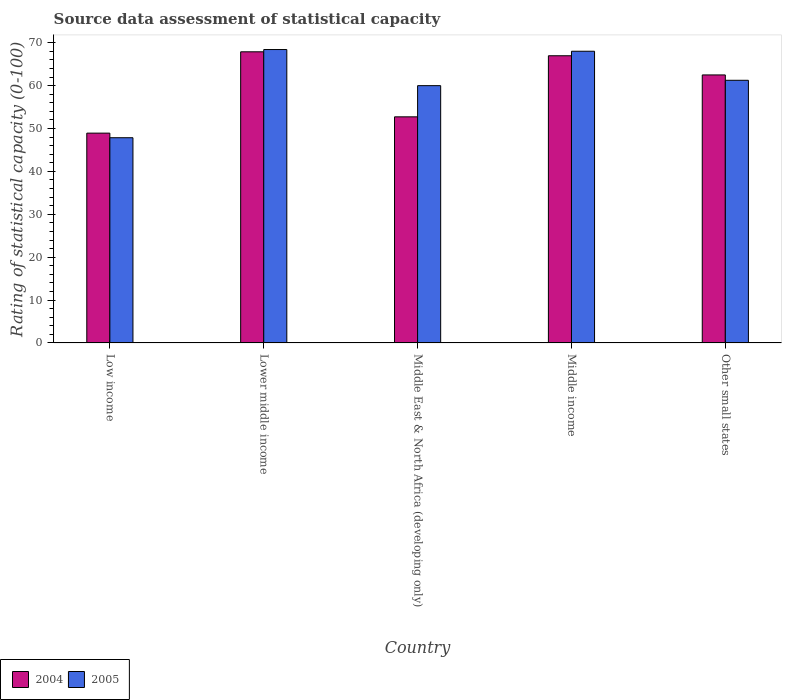How many different coloured bars are there?
Provide a short and direct response. 2. How many groups of bars are there?
Offer a terse response. 5. Are the number of bars per tick equal to the number of legend labels?
Offer a terse response. Yes. How many bars are there on the 1st tick from the left?
Keep it short and to the point. 2. What is the label of the 4th group of bars from the left?
Provide a succinct answer. Middle income. In how many cases, is the number of bars for a given country not equal to the number of legend labels?
Your answer should be compact. 0. What is the rating of statistical capacity in 2004 in Low income?
Keep it short and to the point. 48.93. Across all countries, what is the maximum rating of statistical capacity in 2004?
Provide a succinct answer. 67.89. Across all countries, what is the minimum rating of statistical capacity in 2005?
Give a very brief answer. 47.86. In which country was the rating of statistical capacity in 2004 maximum?
Make the answer very short. Lower middle income. In which country was the rating of statistical capacity in 2004 minimum?
Keep it short and to the point. Low income. What is the total rating of statistical capacity in 2005 in the graph?
Your response must be concise. 305.55. What is the difference between the rating of statistical capacity in 2005 in Low income and that in Middle East & North Africa (developing only)?
Give a very brief answer. -12.14. What is the difference between the rating of statistical capacity in 2004 in Middle income and the rating of statistical capacity in 2005 in Lower middle income?
Provide a succinct answer. -1.45. What is the average rating of statistical capacity in 2004 per country?
Your answer should be compact. 59.8. What is the difference between the rating of statistical capacity of/in 2005 and rating of statistical capacity of/in 2004 in Lower middle income?
Your response must be concise. 0.53. In how many countries, is the rating of statistical capacity in 2005 greater than 62?
Keep it short and to the point. 2. What is the ratio of the rating of statistical capacity in 2004 in Lower middle income to that in Other small states?
Give a very brief answer. 1.09. Is the rating of statistical capacity in 2004 in Low income less than that in Middle income?
Offer a terse response. Yes. Is the difference between the rating of statistical capacity in 2005 in Middle East & North Africa (developing only) and Middle income greater than the difference between the rating of statistical capacity in 2004 in Middle East & North Africa (developing only) and Middle income?
Offer a very short reply. Yes. What is the difference between the highest and the second highest rating of statistical capacity in 2004?
Give a very brief answer. -0.92. What is the difference between the highest and the lowest rating of statistical capacity in 2005?
Provide a succinct answer. 20.56. In how many countries, is the rating of statistical capacity in 2005 greater than the average rating of statistical capacity in 2005 taken over all countries?
Provide a short and direct response. 3. Is the sum of the rating of statistical capacity in 2004 in Lower middle income and Middle East & North Africa (developing only) greater than the maximum rating of statistical capacity in 2005 across all countries?
Keep it short and to the point. Yes. What does the 2nd bar from the left in Middle income represents?
Your response must be concise. 2005. Are all the bars in the graph horizontal?
Offer a terse response. No. How many countries are there in the graph?
Provide a succinct answer. 5. Does the graph contain any zero values?
Ensure brevity in your answer.  No. Does the graph contain grids?
Provide a succinct answer. No. Where does the legend appear in the graph?
Keep it short and to the point. Bottom left. How many legend labels are there?
Your response must be concise. 2. How are the legend labels stacked?
Provide a short and direct response. Horizontal. What is the title of the graph?
Your response must be concise. Source data assessment of statistical capacity. Does "1991" appear as one of the legend labels in the graph?
Your answer should be compact. No. What is the label or title of the X-axis?
Ensure brevity in your answer.  Country. What is the label or title of the Y-axis?
Make the answer very short. Rating of statistical capacity (0-100). What is the Rating of statistical capacity (0-100) of 2004 in Low income?
Make the answer very short. 48.93. What is the Rating of statistical capacity (0-100) in 2005 in Low income?
Ensure brevity in your answer.  47.86. What is the Rating of statistical capacity (0-100) in 2004 in Lower middle income?
Provide a succinct answer. 67.89. What is the Rating of statistical capacity (0-100) of 2005 in Lower middle income?
Provide a short and direct response. 68.42. What is the Rating of statistical capacity (0-100) of 2004 in Middle East & North Africa (developing only)?
Ensure brevity in your answer.  52.73. What is the Rating of statistical capacity (0-100) of 2005 in Middle East & North Africa (developing only)?
Offer a terse response. 60. What is the Rating of statistical capacity (0-100) of 2004 in Middle income?
Offer a very short reply. 66.97. What is the Rating of statistical capacity (0-100) of 2005 in Middle income?
Keep it short and to the point. 68.03. What is the Rating of statistical capacity (0-100) of 2004 in Other small states?
Provide a succinct answer. 62.5. What is the Rating of statistical capacity (0-100) in 2005 in Other small states?
Ensure brevity in your answer.  61.25. Across all countries, what is the maximum Rating of statistical capacity (0-100) in 2004?
Offer a very short reply. 67.89. Across all countries, what is the maximum Rating of statistical capacity (0-100) of 2005?
Your response must be concise. 68.42. Across all countries, what is the minimum Rating of statistical capacity (0-100) of 2004?
Provide a succinct answer. 48.93. Across all countries, what is the minimum Rating of statistical capacity (0-100) of 2005?
Offer a very short reply. 47.86. What is the total Rating of statistical capacity (0-100) in 2004 in the graph?
Offer a terse response. 299.02. What is the total Rating of statistical capacity (0-100) of 2005 in the graph?
Provide a succinct answer. 305.55. What is the difference between the Rating of statistical capacity (0-100) in 2004 in Low income and that in Lower middle income?
Keep it short and to the point. -18.97. What is the difference between the Rating of statistical capacity (0-100) of 2005 in Low income and that in Lower middle income?
Give a very brief answer. -20.56. What is the difference between the Rating of statistical capacity (0-100) in 2004 in Low income and that in Middle East & North Africa (developing only)?
Your answer should be compact. -3.8. What is the difference between the Rating of statistical capacity (0-100) of 2005 in Low income and that in Middle East & North Africa (developing only)?
Your answer should be very brief. -12.14. What is the difference between the Rating of statistical capacity (0-100) in 2004 in Low income and that in Middle income?
Your answer should be compact. -18.05. What is the difference between the Rating of statistical capacity (0-100) of 2005 in Low income and that in Middle income?
Provide a succinct answer. -20.17. What is the difference between the Rating of statistical capacity (0-100) of 2004 in Low income and that in Other small states?
Your answer should be very brief. -13.57. What is the difference between the Rating of statistical capacity (0-100) in 2005 in Low income and that in Other small states?
Offer a very short reply. -13.39. What is the difference between the Rating of statistical capacity (0-100) of 2004 in Lower middle income and that in Middle East & North Africa (developing only)?
Give a very brief answer. 15.17. What is the difference between the Rating of statistical capacity (0-100) in 2005 in Lower middle income and that in Middle East & North Africa (developing only)?
Make the answer very short. 8.42. What is the difference between the Rating of statistical capacity (0-100) of 2004 in Lower middle income and that in Middle income?
Offer a terse response. 0.92. What is the difference between the Rating of statistical capacity (0-100) in 2005 in Lower middle income and that in Middle income?
Ensure brevity in your answer.  0.39. What is the difference between the Rating of statistical capacity (0-100) of 2004 in Lower middle income and that in Other small states?
Offer a very short reply. 5.39. What is the difference between the Rating of statistical capacity (0-100) of 2005 in Lower middle income and that in Other small states?
Your response must be concise. 7.17. What is the difference between the Rating of statistical capacity (0-100) in 2004 in Middle East & North Africa (developing only) and that in Middle income?
Ensure brevity in your answer.  -14.25. What is the difference between the Rating of statistical capacity (0-100) in 2005 in Middle East & North Africa (developing only) and that in Middle income?
Provide a short and direct response. -8.03. What is the difference between the Rating of statistical capacity (0-100) of 2004 in Middle East & North Africa (developing only) and that in Other small states?
Provide a succinct answer. -9.77. What is the difference between the Rating of statistical capacity (0-100) in 2005 in Middle East & North Africa (developing only) and that in Other small states?
Keep it short and to the point. -1.25. What is the difference between the Rating of statistical capacity (0-100) of 2004 in Middle income and that in Other small states?
Give a very brief answer. 4.47. What is the difference between the Rating of statistical capacity (0-100) of 2005 in Middle income and that in Other small states?
Your answer should be compact. 6.78. What is the difference between the Rating of statistical capacity (0-100) of 2004 in Low income and the Rating of statistical capacity (0-100) of 2005 in Lower middle income?
Your answer should be compact. -19.49. What is the difference between the Rating of statistical capacity (0-100) in 2004 in Low income and the Rating of statistical capacity (0-100) in 2005 in Middle East & North Africa (developing only)?
Your answer should be very brief. -11.07. What is the difference between the Rating of statistical capacity (0-100) in 2004 in Low income and the Rating of statistical capacity (0-100) in 2005 in Middle income?
Provide a succinct answer. -19.1. What is the difference between the Rating of statistical capacity (0-100) in 2004 in Low income and the Rating of statistical capacity (0-100) in 2005 in Other small states?
Offer a very short reply. -12.32. What is the difference between the Rating of statistical capacity (0-100) of 2004 in Lower middle income and the Rating of statistical capacity (0-100) of 2005 in Middle East & North Africa (developing only)?
Your answer should be very brief. 7.89. What is the difference between the Rating of statistical capacity (0-100) in 2004 in Lower middle income and the Rating of statistical capacity (0-100) in 2005 in Middle income?
Make the answer very short. -0.13. What is the difference between the Rating of statistical capacity (0-100) in 2004 in Lower middle income and the Rating of statistical capacity (0-100) in 2005 in Other small states?
Offer a very short reply. 6.64. What is the difference between the Rating of statistical capacity (0-100) of 2004 in Middle East & North Africa (developing only) and the Rating of statistical capacity (0-100) of 2005 in Middle income?
Ensure brevity in your answer.  -15.3. What is the difference between the Rating of statistical capacity (0-100) of 2004 in Middle East & North Africa (developing only) and the Rating of statistical capacity (0-100) of 2005 in Other small states?
Provide a short and direct response. -8.52. What is the difference between the Rating of statistical capacity (0-100) of 2004 in Middle income and the Rating of statistical capacity (0-100) of 2005 in Other small states?
Provide a short and direct response. 5.72. What is the average Rating of statistical capacity (0-100) of 2004 per country?
Offer a very short reply. 59.8. What is the average Rating of statistical capacity (0-100) in 2005 per country?
Make the answer very short. 61.11. What is the difference between the Rating of statistical capacity (0-100) of 2004 and Rating of statistical capacity (0-100) of 2005 in Low income?
Your answer should be very brief. 1.07. What is the difference between the Rating of statistical capacity (0-100) in 2004 and Rating of statistical capacity (0-100) in 2005 in Lower middle income?
Your answer should be compact. -0.53. What is the difference between the Rating of statistical capacity (0-100) in 2004 and Rating of statistical capacity (0-100) in 2005 in Middle East & North Africa (developing only)?
Give a very brief answer. -7.27. What is the difference between the Rating of statistical capacity (0-100) of 2004 and Rating of statistical capacity (0-100) of 2005 in Middle income?
Provide a succinct answer. -1.05. What is the difference between the Rating of statistical capacity (0-100) in 2004 and Rating of statistical capacity (0-100) in 2005 in Other small states?
Provide a short and direct response. 1.25. What is the ratio of the Rating of statistical capacity (0-100) of 2004 in Low income to that in Lower middle income?
Your response must be concise. 0.72. What is the ratio of the Rating of statistical capacity (0-100) of 2005 in Low income to that in Lower middle income?
Offer a very short reply. 0.7. What is the ratio of the Rating of statistical capacity (0-100) of 2004 in Low income to that in Middle East & North Africa (developing only)?
Make the answer very short. 0.93. What is the ratio of the Rating of statistical capacity (0-100) of 2005 in Low income to that in Middle East & North Africa (developing only)?
Your answer should be very brief. 0.8. What is the ratio of the Rating of statistical capacity (0-100) in 2004 in Low income to that in Middle income?
Your response must be concise. 0.73. What is the ratio of the Rating of statistical capacity (0-100) in 2005 in Low income to that in Middle income?
Offer a terse response. 0.7. What is the ratio of the Rating of statistical capacity (0-100) of 2004 in Low income to that in Other small states?
Keep it short and to the point. 0.78. What is the ratio of the Rating of statistical capacity (0-100) in 2005 in Low income to that in Other small states?
Offer a terse response. 0.78. What is the ratio of the Rating of statistical capacity (0-100) in 2004 in Lower middle income to that in Middle East & North Africa (developing only)?
Make the answer very short. 1.29. What is the ratio of the Rating of statistical capacity (0-100) of 2005 in Lower middle income to that in Middle East & North Africa (developing only)?
Offer a very short reply. 1.14. What is the ratio of the Rating of statistical capacity (0-100) in 2004 in Lower middle income to that in Middle income?
Ensure brevity in your answer.  1.01. What is the ratio of the Rating of statistical capacity (0-100) of 2004 in Lower middle income to that in Other small states?
Your response must be concise. 1.09. What is the ratio of the Rating of statistical capacity (0-100) of 2005 in Lower middle income to that in Other small states?
Offer a very short reply. 1.12. What is the ratio of the Rating of statistical capacity (0-100) of 2004 in Middle East & North Africa (developing only) to that in Middle income?
Offer a very short reply. 0.79. What is the ratio of the Rating of statistical capacity (0-100) of 2005 in Middle East & North Africa (developing only) to that in Middle income?
Keep it short and to the point. 0.88. What is the ratio of the Rating of statistical capacity (0-100) in 2004 in Middle East & North Africa (developing only) to that in Other small states?
Give a very brief answer. 0.84. What is the ratio of the Rating of statistical capacity (0-100) in 2005 in Middle East & North Africa (developing only) to that in Other small states?
Your answer should be compact. 0.98. What is the ratio of the Rating of statistical capacity (0-100) of 2004 in Middle income to that in Other small states?
Keep it short and to the point. 1.07. What is the ratio of the Rating of statistical capacity (0-100) in 2005 in Middle income to that in Other small states?
Offer a terse response. 1.11. What is the difference between the highest and the second highest Rating of statistical capacity (0-100) in 2004?
Offer a terse response. 0.92. What is the difference between the highest and the second highest Rating of statistical capacity (0-100) of 2005?
Ensure brevity in your answer.  0.39. What is the difference between the highest and the lowest Rating of statistical capacity (0-100) of 2004?
Provide a succinct answer. 18.97. What is the difference between the highest and the lowest Rating of statistical capacity (0-100) of 2005?
Your response must be concise. 20.56. 